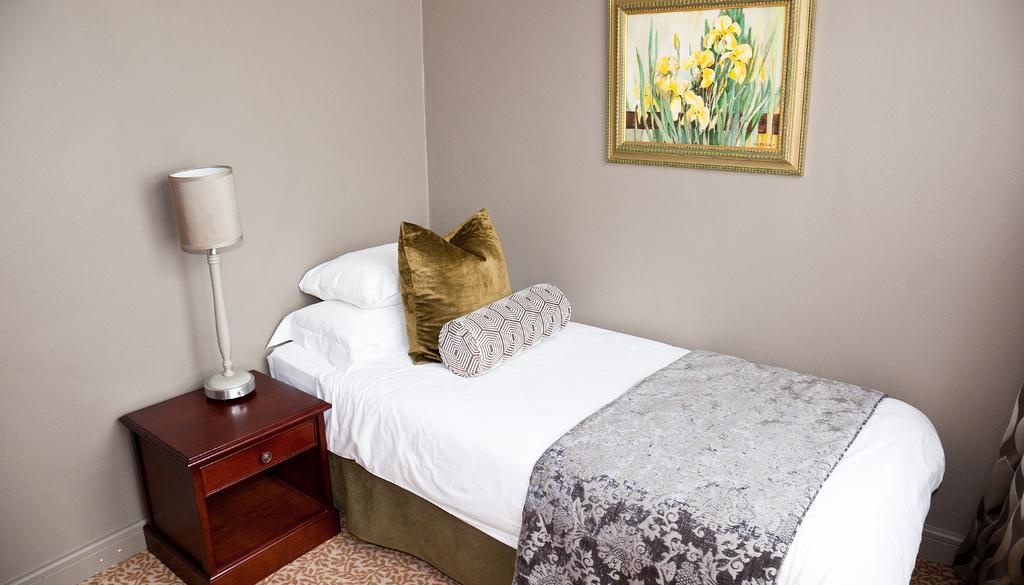What type of furniture is present in the image? There is a bed, a table, and a light lamp in the image. What is placed on the bed? There is a blanket and a pillow on the bed. What decorative item can be seen in the image? There is a photo frame in the image. What type of flooring is visible in the image? There is a carpet in the image. What type of plants can be seen growing near the harbor in the image? There is no harbor or plants present in the image; it features a bedroom setting with a bed, table, light lamp, blanket, pillow, photo frame, and carpet. What type of laborer is depicted in the image? There is no laborer depicted in the image; it features a bedroom setting with a bed, table, light lamp, blanket, pillow, photo frame, and carpet. 